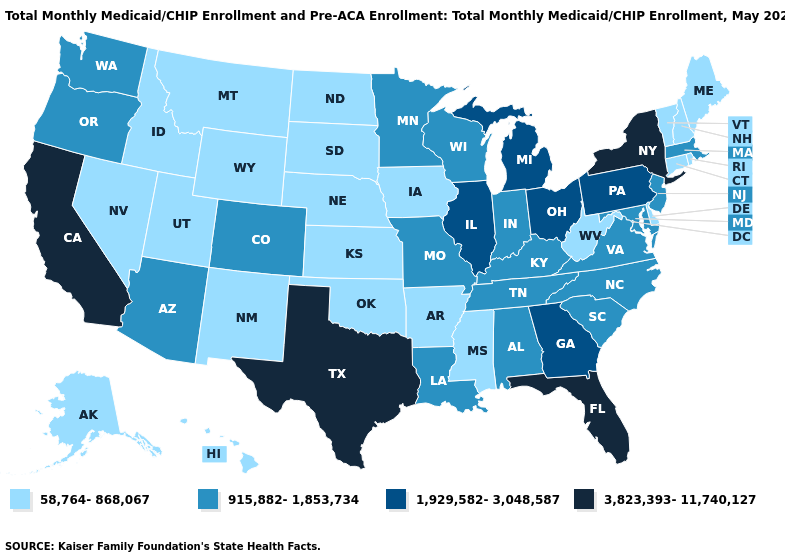What is the value of Arizona?
Short answer required. 915,882-1,853,734. Which states have the highest value in the USA?
Keep it brief. California, Florida, New York, Texas. Name the states that have a value in the range 3,823,393-11,740,127?
Keep it brief. California, Florida, New York, Texas. Does Rhode Island have the lowest value in the USA?
Answer briefly. Yes. Which states have the highest value in the USA?
Give a very brief answer. California, Florida, New York, Texas. What is the lowest value in the West?
Give a very brief answer. 58,764-868,067. Name the states that have a value in the range 3,823,393-11,740,127?
Give a very brief answer. California, Florida, New York, Texas. What is the highest value in the MidWest ?
Short answer required. 1,929,582-3,048,587. Name the states that have a value in the range 1,929,582-3,048,587?
Be succinct. Georgia, Illinois, Michigan, Ohio, Pennsylvania. Does Utah have the lowest value in the USA?
Give a very brief answer. Yes. Name the states that have a value in the range 3,823,393-11,740,127?
Be succinct. California, Florida, New York, Texas. Which states have the lowest value in the USA?
Write a very short answer. Alaska, Arkansas, Connecticut, Delaware, Hawaii, Idaho, Iowa, Kansas, Maine, Mississippi, Montana, Nebraska, Nevada, New Hampshire, New Mexico, North Dakota, Oklahoma, Rhode Island, South Dakota, Utah, Vermont, West Virginia, Wyoming. What is the value of Nebraska?
Give a very brief answer. 58,764-868,067. What is the value of Iowa?
Concise answer only. 58,764-868,067. Which states have the lowest value in the West?
Quick response, please. Alaska, Hawaii, Idaho, Montana, Nevada, New Mexico, Utah, Wyoming. 